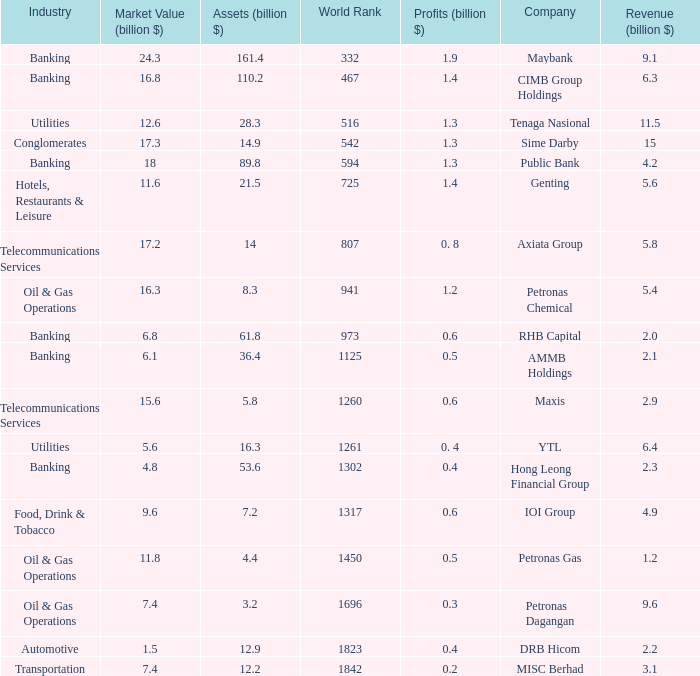Help me parse the entirety of this table. {'header': ['Industry', 'Market Value (billion $)', 'Assets (billion $)', 'World Rank', 'Profits (billion $)', 'Company', 'Revenue (billion $)'], 'rows': [['Banking', '24.3', '161.4', '332', '1.9', 'Maybank', '9.1'], ['Banking', '16.8', '110.2', '467', '1.4', 'CIMB Group Holdings', '6.3'], ['Utilities', '12.6', '28.3', '516', '1.3', 'Tenaga Nasional', '11.5'], ['Conglomerates', '17.3', '14.9', '542', '1.3', 'Sime Darby', '15'], ['Banking', '18', '89.8', '594', '1.3', 'Public Bank', '4.2'], ['Hotels, Restaurants & Leisure', '11.6', '21.5', '725', '1.4', 'Genting', '5.6'], ['Telecommunications Services', '17.2', '14', '807', '0. 8', 'Axiata Group', '5.8'], ['Oil & Gas Operations', '16.3', '8.3', '941', '1.2', 'Petronas Chemical', '5.4'], ['Banking', '6.8', '61.8', '973', '0.6', 'RHB Capital', '2.0'], ['Banking', '6.1', '36.4', '1125', '0.5', 'AMMB Holdings', '2.1'], ['Telecommunications Services', '15.6', '5.8', '1260', '0.6', 'Maxis', '2.9'], ['Utilities', '5.6', '16.3', '1261', '0. 4', 'YTL', '6.4'], ['Banking', '4.8', '53.6', '1302', '0.4', 'Hong Leong Financial Group', '2.3'], ['Food, Drink & Tobacco', '9.6', '7.2', '1317', '0.6', 'IOI Group', '4.9'], ['Oil & Gas Operations', '11.8', '4.4', '1450', '0.5', 'Petronas Gas', '1.2'], ['Oil & Gas Operations', '7.4', '3.2', '1696', '0.3', 'Petronas Dagangan', '9.6'], ['Automotive', '1.5', '12.9', '1823', '0.4', 'DRB Hicom', '2.2'], ['Transportation', '7.4', '12.2', '1842', '0.2', 'MISC Berhad', '3.1']]} Name the industry for revenue being 2.1 Banking. 